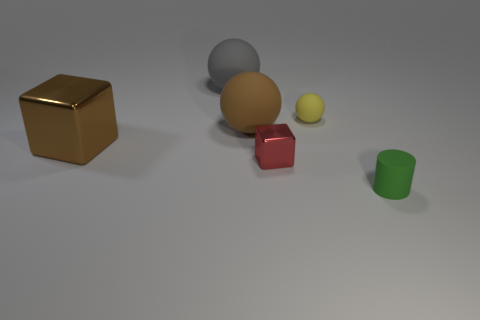What number of things are small yellow objects or rubber objects that are to the right of the large gray matte thing? There are two objects that fit the description: one small yellow sphere and one red rubber cube, both located to the right of the large gray sphere. 